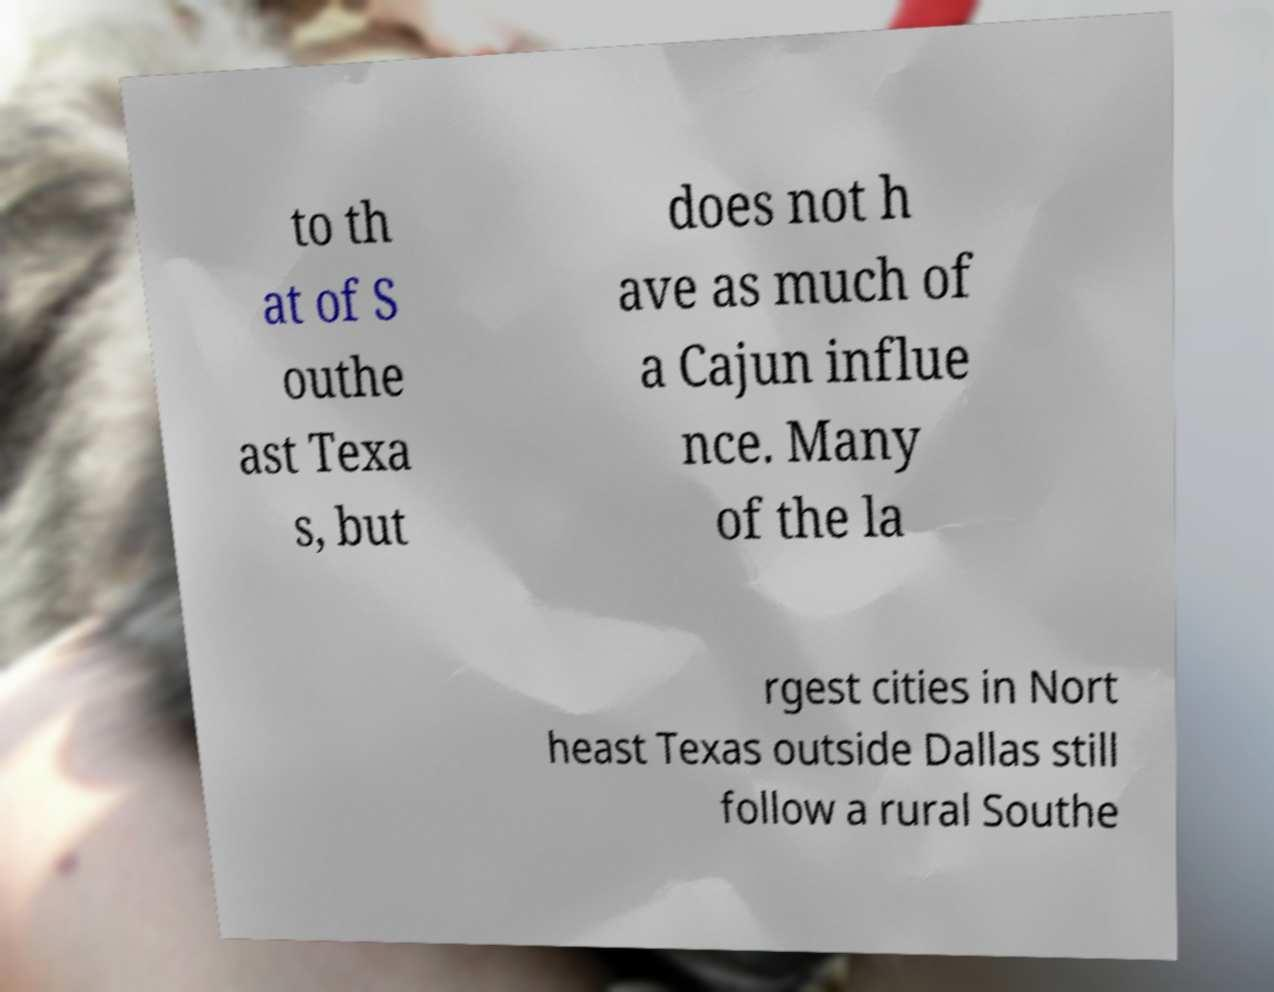There's text embedded in this image that I need extracted. Can you transcribe it verbatim? to th at of S outhe ast Texa s, but does not h ave as much of a Cajun influe nce. Many of the la rgest cities in Nort heast Texas outside Dallas still follow a rural Southe 